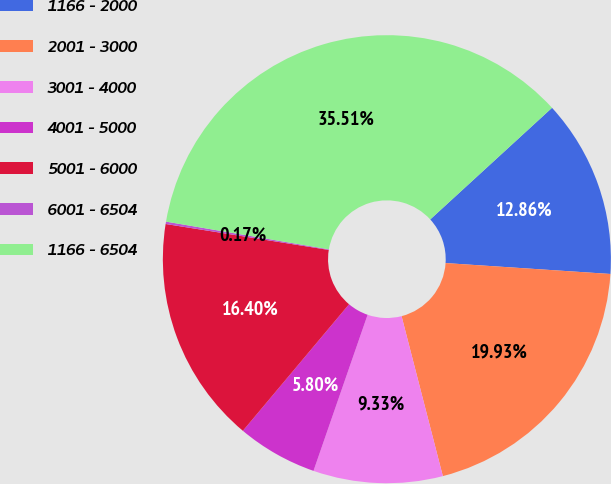Convert chart. <chart><loc_0><loc_0><loc_500><loc_500><pie_chart><fcel>1166 - 2000<fcel>2001 - 3000<fcel>3001 - 4000<fcel>4001 - 5000<fcel>5001 - 6000<fcel>6001 - 6504<fcel>1166 - 6504<nl><fcel>12.86%<fcel>19.93%<fcel>9.33%<fcel>5.8%<fcel>16.4%<fcel>0.17%<fcel>35.51%<nl></chart> 